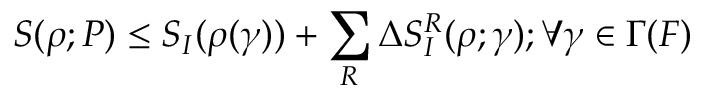Convert formula to latex. <formula><loc_0><loc_0><loc_500><loc_500>S ( \rho ; P ) \leq S _ { I } ( \rho ( \gamma ) ) + \sum _ { R } \Delta S _ { I } ^ { R } ( \rho ; \gamma ) ; \forall \gamma \in \Gamma ( F )</formula> 